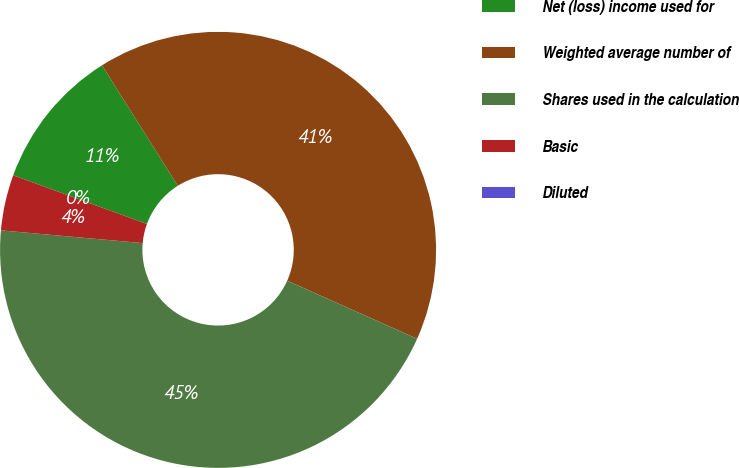Convert chart to OTSL. <chart><loc_0><loc_0><loc_500><loc_500><pie_chart><fcel>Net (loss) income used for<fcel>Weighted average number of<fcel>Shares used in the calculation<fcel>Basic<fcel>Diluted<nl><fcel>10.51%<fcel>40.62%<fcel>44.74%<fcel>4.13%<fcel>0.0%<nl></chart> 